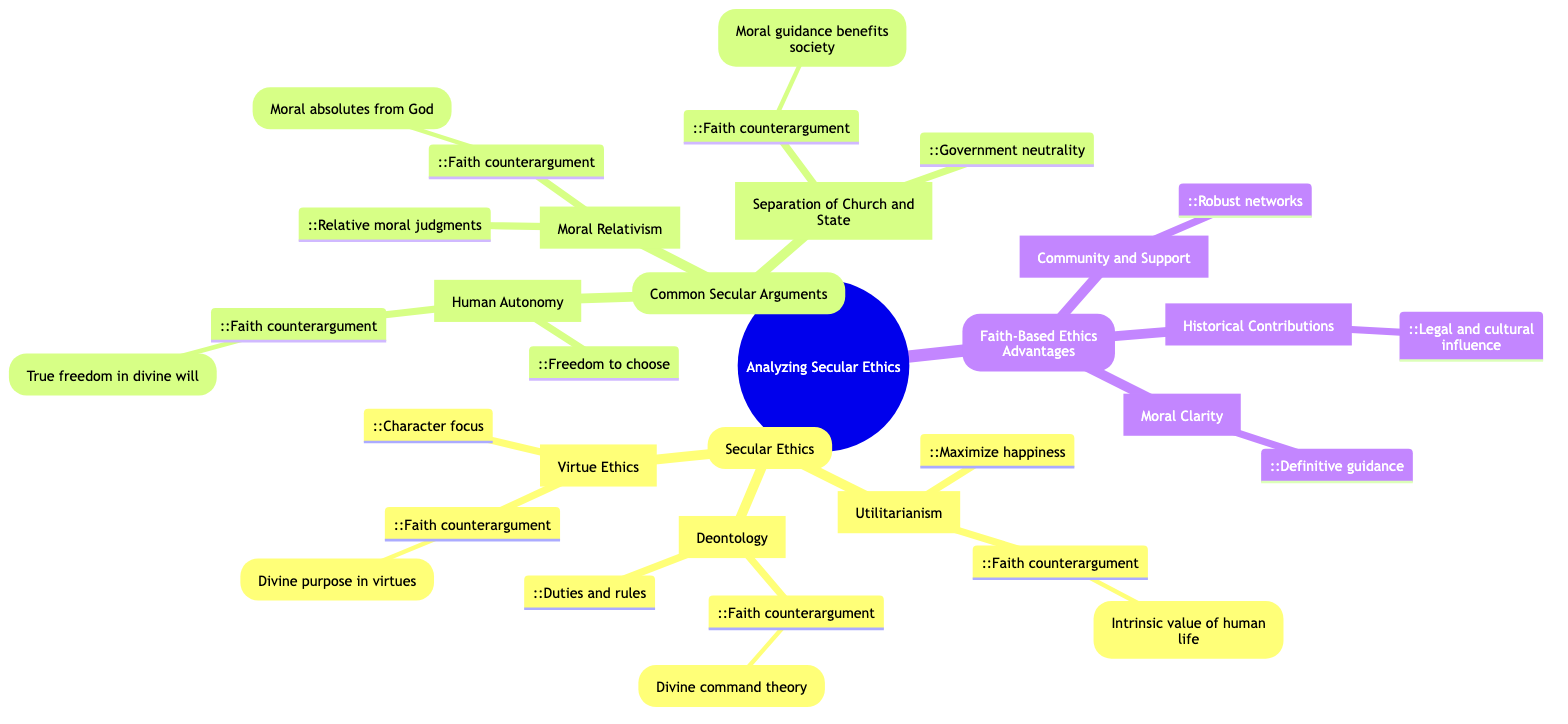What are the three main branches of secular ethics? The mind map identifies three primary branches of secular ethics: Utilitarianism, Deontology, and Virtue Ethics. This can be determined by looking at the labeled nodes under the "Secular Ethics" branch.
Answer: Utilitarianism, Deontology, Virtue Ethics What does Utilitarianism advocate for? The diagram clearly states that Utilitarianism advocates for actions that maximize happiness and well-being for the majority, as indicated in its description.
Answer: Maximize happiness What is the faith-based counterargument to Deontology? According to the diagram, the faith-based counterargument to Deontology highlights that moral obligations come from God's will, which is described as divine command theory. This combines the description of Deontology with its corresponding faith-based counterargument.
Answer: Divine command theory How many common secular arguments are presented in the mind map? The mind map lists three common secular arguments, which are Moral Relativism, Human Autonomy, and Separation of Church and State. This can be counted by identifying the labeled nodes under the "Common Secular Arguments" branch.
Answer: 3 What role do virtues play according to faith-based ethics? The mind map states that faith-based ethics frame virtues as aligning with God's character, which indicates their divinely purposeful role. This is derived from the description under Virtue Ethics and its faith-based counterargument.
Answer: Aligning with God's character What is the main concern with moral relativism expressed in the faith-based counterargument? The faith-based counterargument against moral relativism argues that if morality is relative, then concepts like justice lose meaning, which is a critical concern highlighted in the diagram. This involves synthesizing information from the common secular argument and its counterargument.
Answer: Concepts like justice lose meaning Which advantage of faith-based ethics provides support networks? The mind map states that the advantage of faith-based ethics related to support networks is labeled as "Community and Support," which indicates its role in providing robust networks. This can be gathered from the advantages listed under "Faith-Based Ethics Advantages."
Answer: Community and Support How does the faith-based perspective view the separation of church and state? The diagram emphasizes that the faith-based counterargument does not view moral direction as theocratic governance but as beneficial for society, specifically arguing for the moral guidance informed by faith. This connects the "Separation of Church and State" argument with its response.
Answer: Moral guidance benefits society What is the description of faith-based ethical advantages related to moral clarity? The description indicates that faith-based ethics provide definitive guidance on many ethical issues, as shown under the "Moral Clarity" node. This can be found directly in the corresponding section of the mind map.
Answer: Definitive guidance 